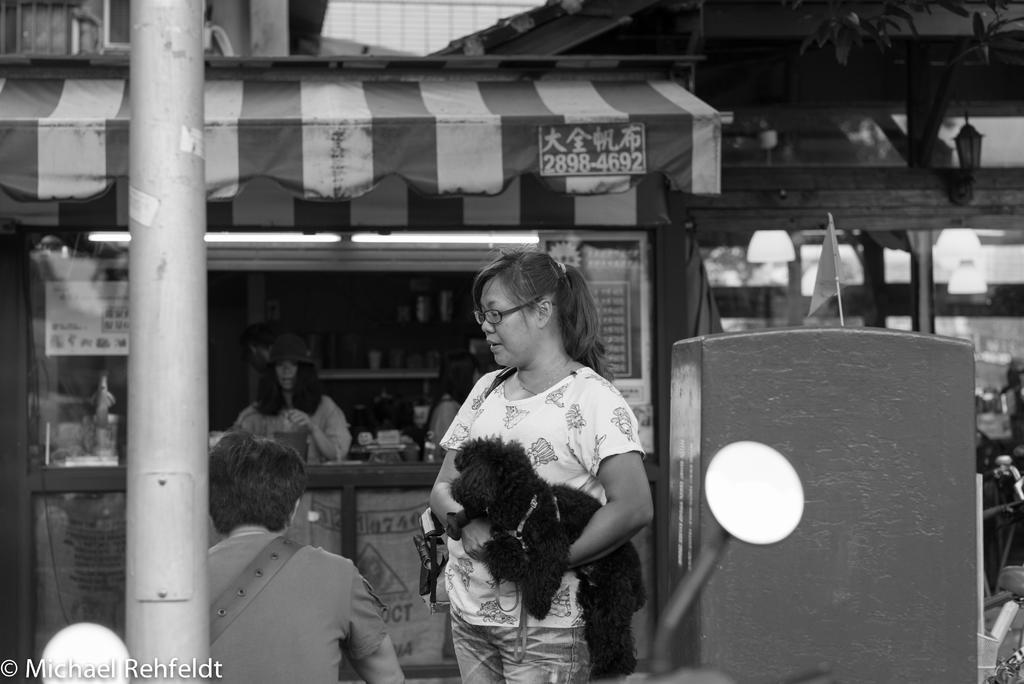Could you give a brief overview of what you see in this image? This picture is clicked outside there is a woman wearing t-shirt, sling bag, holding a dog and standing. On the left we can see the two persons and a metal rod. On the right there is a mirror and we can see many other objects. In the center we can see the tents and many other objects. In the top right corner we can see the leaves and a lamp. In the bottom left corner there is a text on the image. 